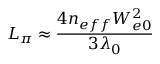Convert formula to latex. <formula><loc_0><loc_0><loc_500><loc_500>L _ { \pi } \approx \frac { 4 n _ { e f f } W _ { e 0 } ^ { 2 } } { 3 \lambda _ { 0 } }</formula> 